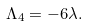<formula> <loc_0><loc_0><loc_500><loc_500>\Lambda _ { 4 } = - 6 \lambda .</formula> 